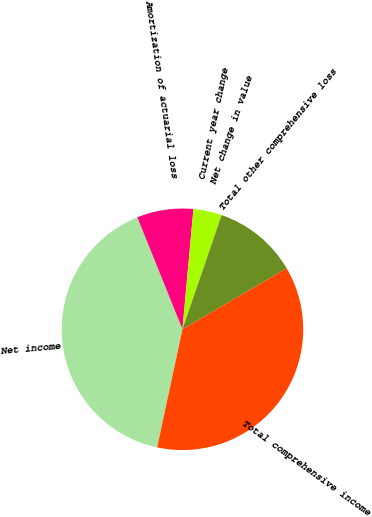<chart> <loc_0><loc_0><loc_500><loc_500><pie_chart><fcel>Net income<fcel>Amortization of actuarial loss<fcel>Current year change<fcel>Net change in value<fcel>Total other comprehensive loss<fcel>Total comprehensive income<nl><fcel>40.55%<fcel>7.54%<fcel>3.79%<fcel>0.03%<fcel>11.3%<fcel>36.79%<nl></chart> 